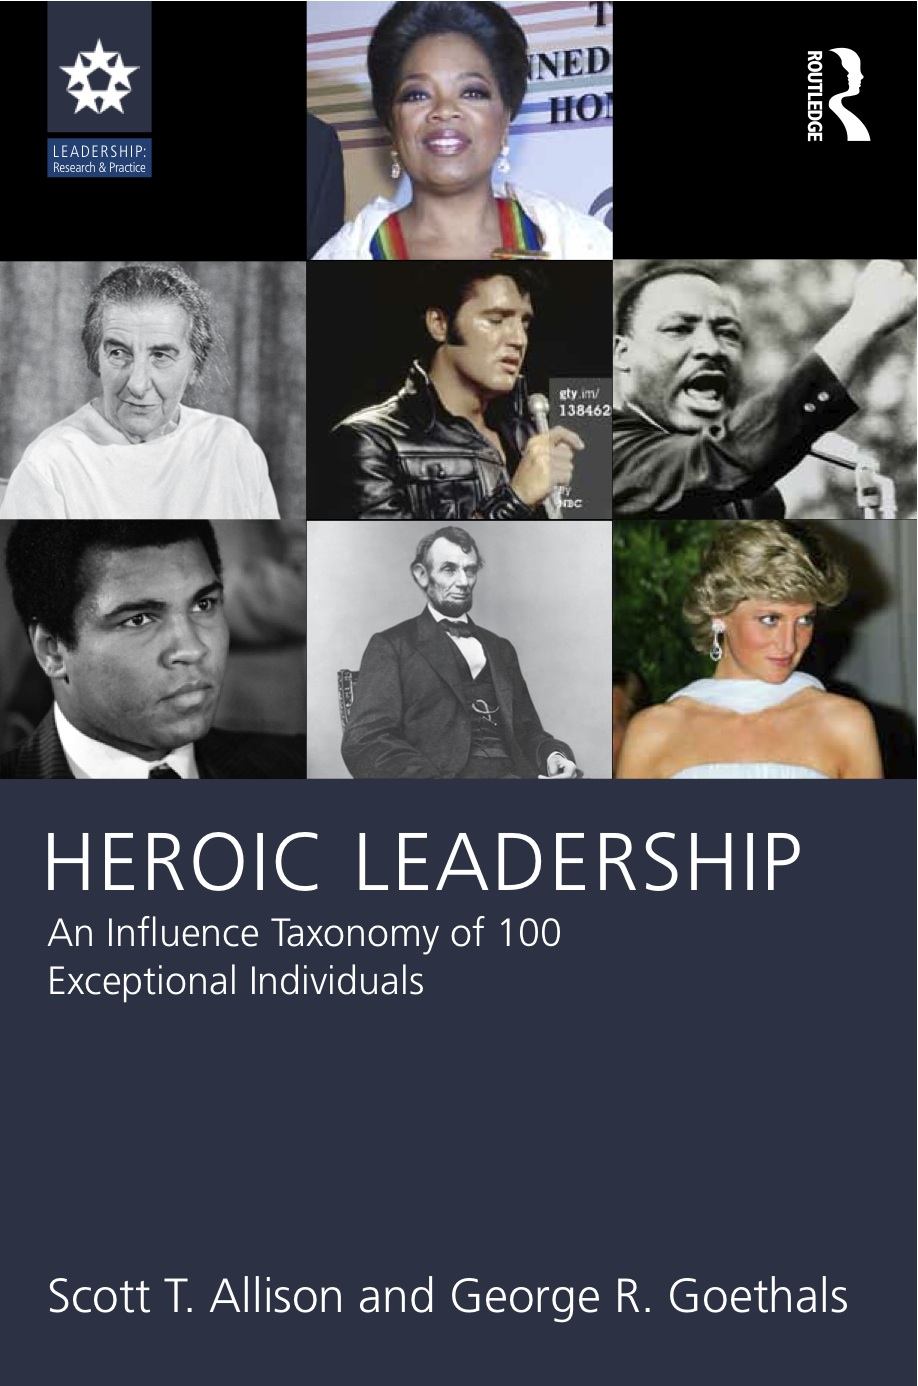Explore the historical context around the Black and white image in the middle row, right. What key message does this leader's inclusion on the cover send about the concept of 'Heroic Leadership'? This image depicts a renowned civil rights leader whose historic speech and leadership during critical protests marked significant milestones in the civil rights movement. His inclusion on the cover symbolizes the importance of visionary leadership and the courage to challenge systemic injustice. 'Heroic Leadership' in this context emphasizes the ability to lead with empathy, integrity, and a steadfast commitment to equality and human rights. 